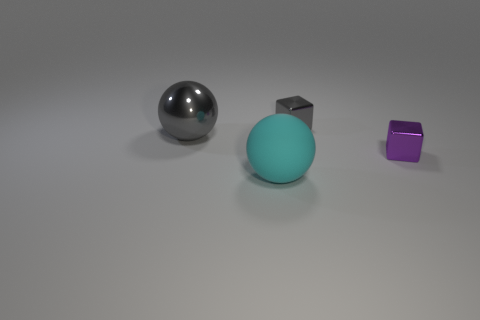Add 2 large rubber spheres. How many objects exist? 6 Subtract all purple cubes. How many cubes are left? 1 Add 1 tiny spheres. How many tiny spheres exist? 1 Subtract 0 blue blocks. How many objects are left? 4 Subtract all blue balls. Subtract all yellow blocks. How many balls are left? 2 Subtract all big rubber spheres. Subtract all red spheres. How many objects are left? 3 Add 4 big cyan spheres. How many big cyan spheres are left? 5 